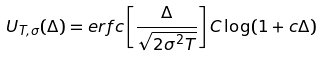<formula> <loc_0><loc_0><loc_500><loc_500>U _ { T , \sigma } ( \Delta ) = e r f c \left [ \frac { \Delta } { \sqrt { 2 \sigma ^ { 2 } T } } \right ] C \log ( 1 + c \Delta )</formula> 